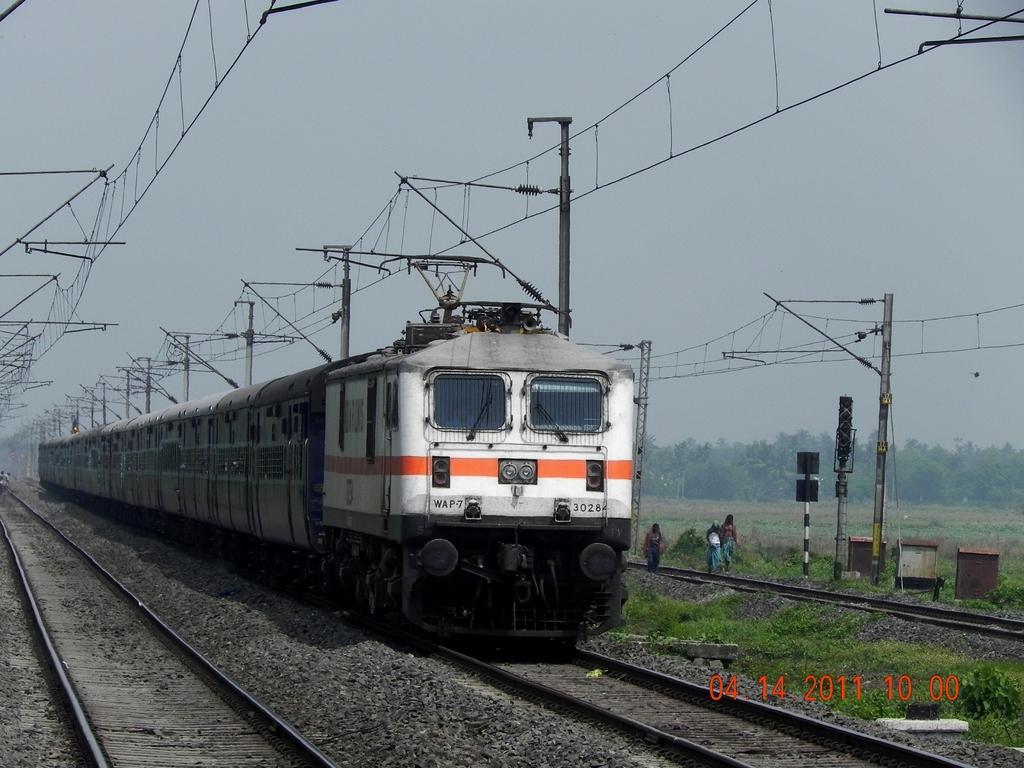Please provide a concise description of this image. In this picture we can see a train on a railway track, poles, grass, trees and three persons walking on the ground and in the background we can see the sky. 